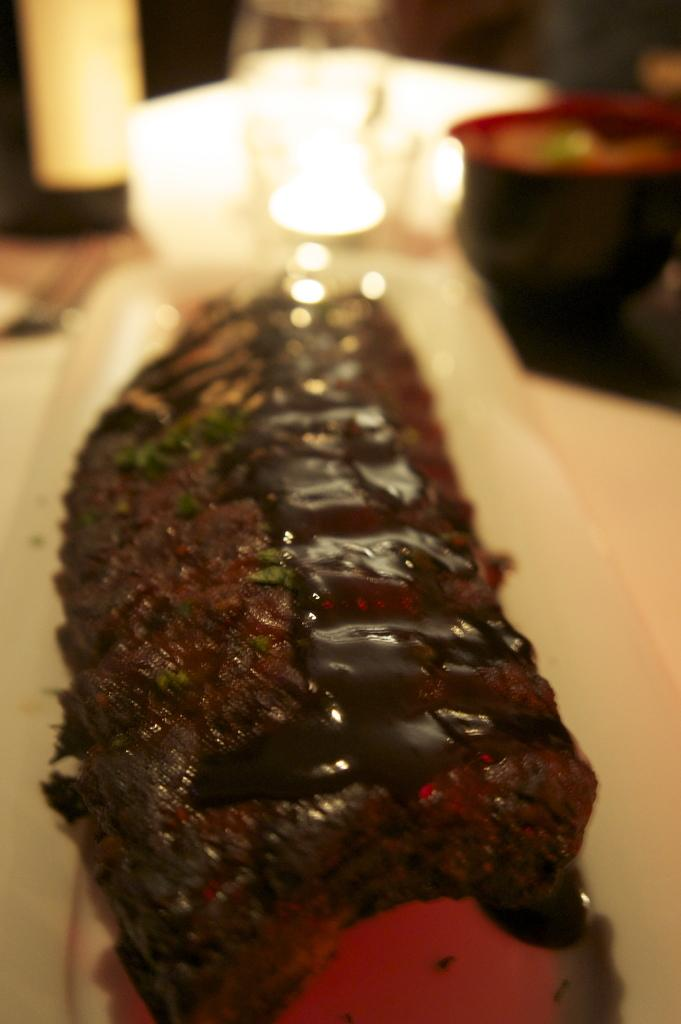What is the main subject of the image? There is a food item in a plate in the image. Can you describe the background of the image? The background of the image is blurred. What type of knee can be seen in the image? There is no knee present in the image. How does the feather change the appearance of the food item in the image? There is no feather present in the image, so it cannot change the appearance of the food item. 